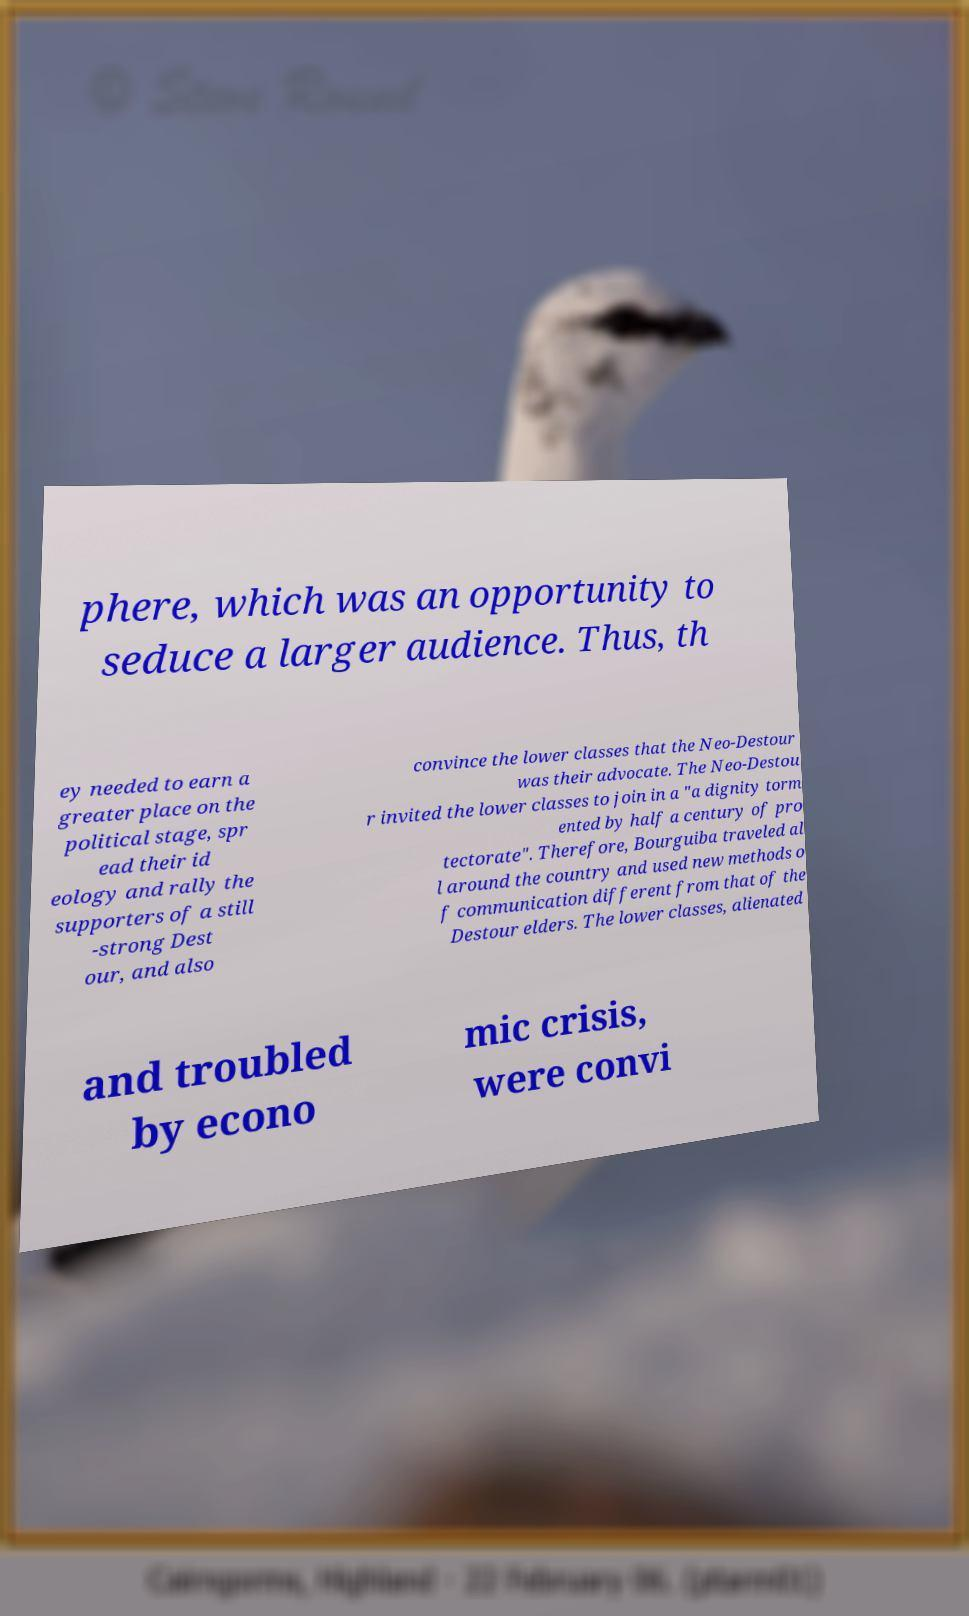Can you read and provide the text displayed in the image?This photo seems to have some interesting text. Can you extract and type it out for me? phere, which was an opportunity to seduce a larger audience. Thus, th ey needed to earn a greater place on the political stage, spr ead their id eology and rally the supporters of a still -strong Dest our, and also convince the lower classes that the Neo-Destour was their advocate. The Neo-Destou r invited the lower classes to join in a "a dignity torm ented by half a century of pro tectorate". Therefore, Bourguiba traveled al l around the country and used new methods o f communication different from that of the Destour elders. The lower classes, alienated and troubled by econo mic crisis, were convi 